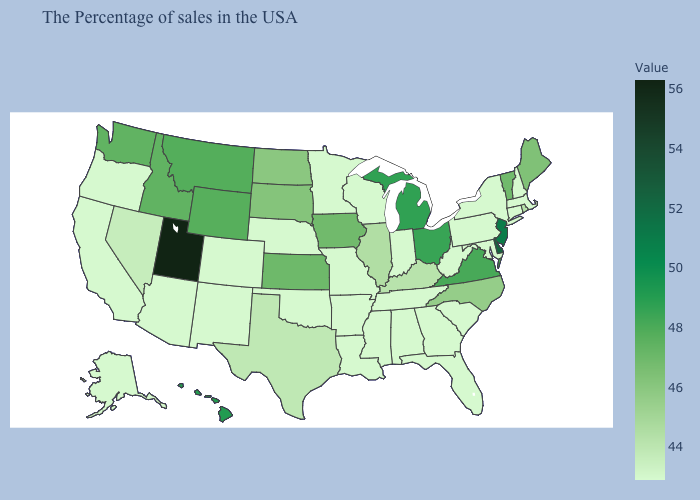Does Kansas have the lowest value in the USA?
Answer briefly. No. Does Mississippi have a lower value than Maine?
Concise answer only. Yes. Does New York have a higher value than Ohio?
Answer briefly. No. Among the states that border New Hampshire , does Vermont have the lowest value?
Concise answer only. No. Does the map have missing data?
Keep it brief. No. Does Georgia have the lowest value in the South?
Answer briefly. Yes. 